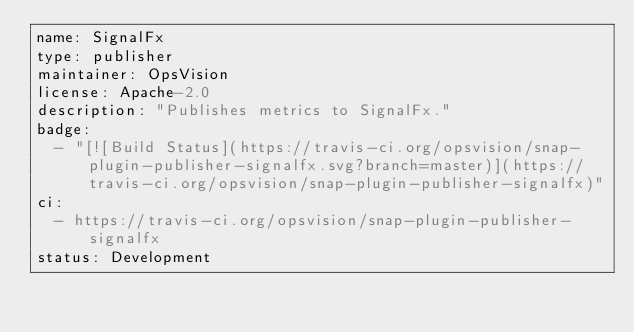Convert code to text. <code><loc_0><loc_0><loc_500><loc_500><_YAML_>name: SignalFx
type: publisher
maintainer: OpsVision
license: Apache-2.0
description: "Publishes metrics to SignalFx."
badge:
  - "[![Build Status](https://travis-ci.org/opsvision/snap-plugin-publisher-signalfx.svg?branch=master)](https://travis-ci.org/opsvision/snap-plugin-publisher-signalfx)"
ci:
  - https://travis-ci.org/opsvision/snap-plugin-publisher-signalfx
status: Development
</code> 